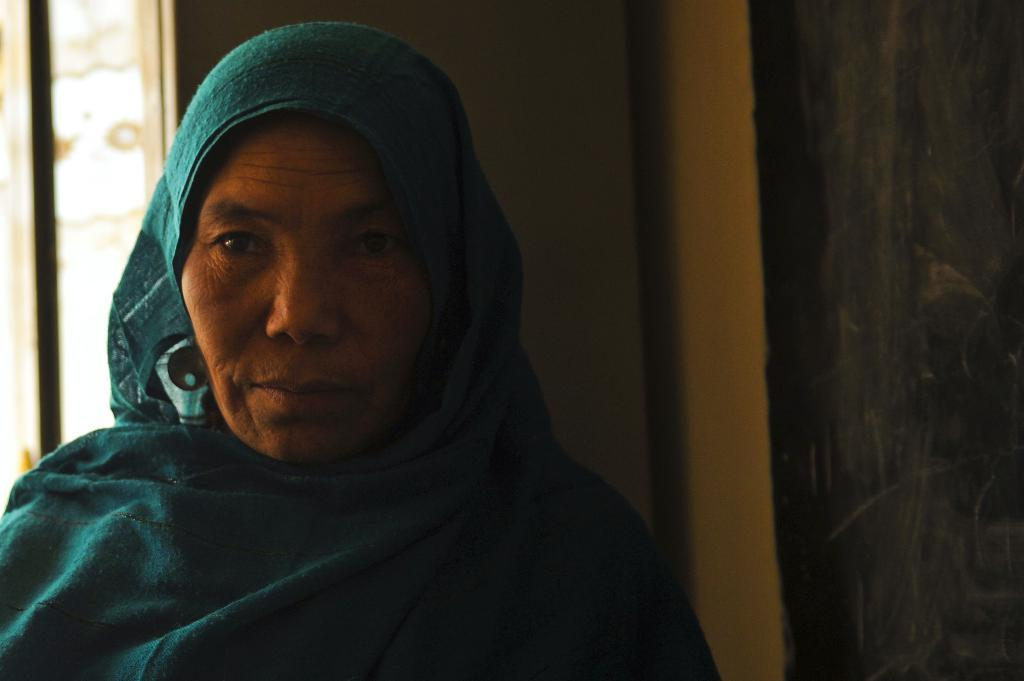Who is the main subject in the image? There is an old woman in the image. What is the old woman wearing on her head? The old woman is wearing a sea green color cloth over her head. Where is the old woman standing in the image? The old woman is standing beside a wall. What can be seen on the wall behind her? There appears to be a window on the wall behind her. What type of wine is the old woman holding in the image? There is no wine present in the image; the old woman is not holding any wine. 